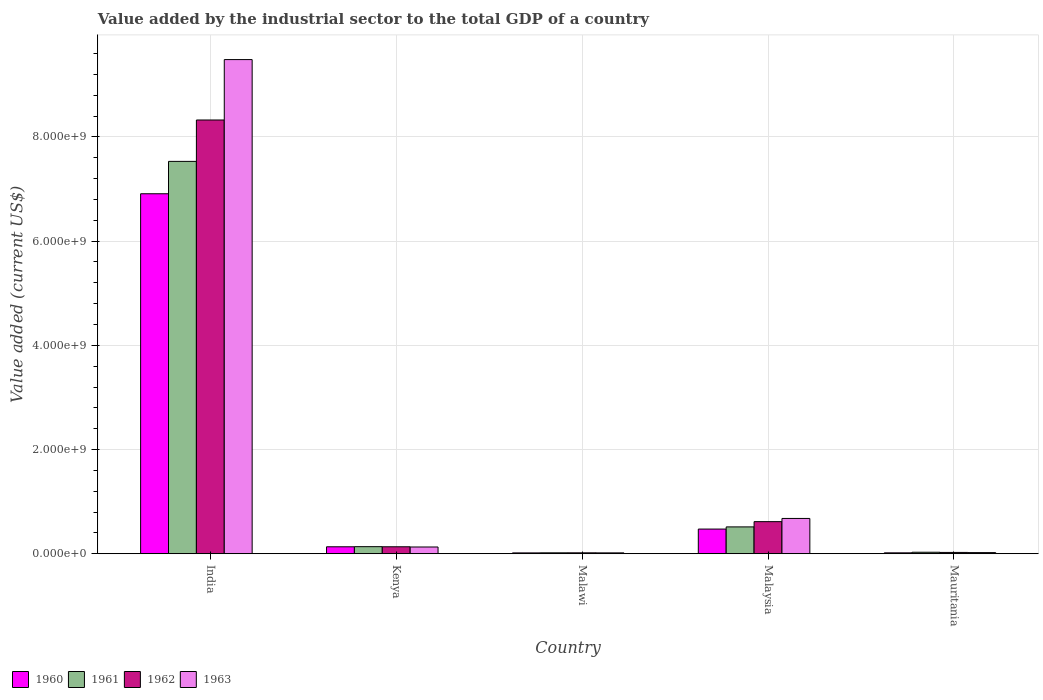How many different coloured bars are there?
Offer a terse response. 4. How many groups of bars are there?
Your answer should be compact. 5. Are the number of bars per tick equal to the number of legend labels?
Ensure brevity in your answer.  Yes. How many bars are there on the 4th tick from the left?
Your answer should be very brief. 4. How many bars are there on the 5th tick from the right?
Provide a succinct answer. 4. What is the label of the 4th group of bars from the left?
Your response must be concise. Malaysia. What is the value added by the industrial sector to the total GDP in 1962 in Mauritania?
Provide a succinct answer. 2.52e+07. Across all countries, what is the maximum value added by the industrial sector to the total GDP in 1961?
Your answer should be very brief. 7.53e+09. Across all countries, what is the minimum value added by the industrial sector to the total GDP in 1962?
Provide a succinct answer. 1.78e+07. In which country was the value added by the industrial sector to the total GDP in 1962 maximum?
Offer a very short reply. India. In which country was the value added by the industrial sector to the total GDP in 1963 minimum?
Offer a very short reply. Malawi. What is the total value added by the industrial sector to the total GDP in 1963 in the graph?
Give a very brief answer. 1.03e+1. What is the difference between the value added by the industrial sector to the total GDP in 1963 in India and that in Kenya?
Provide a succinct answer. 9.36e+09. What is the difference between the value added by the industrial sector to the total GDP in 1962 in India and the value added by the industrial sector to the total GDP in 1961 in Malawi?
Give a very brief answer. 8.31e+09. What is the average value added by the industrial sector to the total GDP in 1962 per country?
Offer a very short reply. 1.82e+09. What is the difference between the value added by the industrial sector to the total GDP of/in 1961 and value added by the industrial sector to the total GDP of/in 1962 in Kenya?
Offer a terse response. 1.96e+06. What is the ratio of the value added by the industrial sector to the total GDP in 1961 in Malawi to that in Mauritania?
Provide a succinct answer. 0.61. Is the value added by the industrial sector to the total GDP in 1961 in India less than that in Kenya?
Ensure brevity in your answer.  No. What is the difference between the highest and the second highest value added by the industrial sector to the total GDP in 1963?
Your response must be concise. 9.36e+09. What is the difference between the highest and the lowest value added by the industrial sector to the total GDP in 1961?
Your answer should be compact. 7.51e+09. In how many countries, is the value added by the industrial sector to the total GDP in 1960 greater than the average value added by the industrial sector to the total GDP in 1960 taken over all countries?
Your answer should be compact. 1. Is it the case that in every country, the sum of the value added by the industrial sector to the total GDP in 1961 and value added by the industrial sector to the total GDP in 1960 is greater than the sum of value added by the industrial sector to the total GDP in 1963 and value added by the industrial sector to the total GDP in 1962?
Offer a terse response. No. Are all the bars in the graph horizontal?
Your answer should be compact. No. How many countries are there in the graph?
Your answer should be compact. 5. Are the values on the major ticks of Y-axis written in scientific E-notation?
Offer a very short reply. Yes. Does the graph contain any zero values?
Your response must be concise. No. Does the graph contain grids?
Your answer should be very brief. Yes. Where does the legend appear in the graph?
Give a very brief answer. Bottom left. What is the title of the graph?
Ensure brevity in your answer.  Value added by the industrial sector to the total GDP of a country. Does "1997" appear as one of the legend labels in the graph?
Your response must be concise. No. What is the label or title of the X-axis?
Provide a short and direct response. Country. What is the label or title of the Y-axis?
Your answer should be compact. Value added (current US$). What is the Value added (current US$) of 1960 in India?
Your answer should be very brief. 6.91e+09. What is the Value added (current US$) in 1961 in India?
Offer a very short reply. 7.53e+09. What is the Value added (current US$) of 1962 in India?
Your answer should be very brief. 8.33e+09. What is the Value added (current US$) in 1963 in India?
Provide a succinct answer. 9.49e+09. What is the Value added (current US$) of 1960 in Kenya?
Your answer should be compact. 1.34e+08. What is the Value added (current US$) of 1961 in Kenya?
Offer a terse response. 1.36e+08. What is the Value added (current US$) in 1962 in Kenya?
Your answer should be compact. 1.34e+08. What is the Value added (current US$) of 1963 in Kenya?
Give a very brief answer. 1.30e+08. What is the Value added (current US$) in 1960 in Malawi?
Ensure brevity in your answer.  1.62e+07. What is the Value added (current US$) of 1961 in Malawi?
Offer a terse response. 1.76e+07. What is the Value added (current US$) of 1962 in Malawi?
Give a very brief answer. 1.78e+07. What is the Value added (current US$) of 1963 in Malawi?
Your answer should be compact. 1.69e+07. What is the Value added (current US$) of 1960 in Malaysia?
Provide a short and direct response. 4.74e+08. What is the Value added (current US$) in 1961 in Malaysia?
Provide a succinct answer. 5.15e+08. What is the Value added (current US$) of 1962 in Malaysia?
Ensure brevity in your answer.  6.16e+08. What is the Value added (current US$) of 1963 in Malaysia?
Provide a succinct answer. 6.77e+08. What is the Value added (current US$) of 1960 in Mauritania?
Provide a short and direct response. 1.73e+07. What is the Value added (current US$) in 1961 in Mauritania?
Make the answer very short. 2.88e+07. What is the Value added (current US$) of 1962 in Mauritania?
Offer a very short reply. 2.52e+07. What is the Value added (current US$) of 1963 in Mauritania?
Give a very brief answer. 2.18e+07. Across all countries, what is the maximum Value added (current US$) of 1960?
Make the answer very short. 6.91e+09. Across all countries, what is the maximum Value added (current US$) of 1961?
Your answer should be very brief. 7.53e+09. Across all countries, what is the maximum Value added (current US$) of 1962?
Ensure brevity in your answer.  8.33e+09. Across all countries, what is the maximum Value added (current US$) in 1963?
Offer a very short reply. 9.49e+09. Across all countries, what is the minimum Value added (current US$) of 1960?
Your answer should be very brief. 1.62e+07. Across all countries, what is the minimum Value added (current US$) of 1961?
Give a very brief answer. 1.76e+07. Across all countries, what is the minimum Value added (current US$) in 1962?
Your response must be concise. 1.78e+07. Across all countries, what is the minimum Value added (current US$) in 1963?
Your response must be concise. 1.69e+07. What is the total Value added (current US$) in 1960 in the graph?
Your answer should be compact. 7.55e+09. What is the total Value added (current US$) in 1961 in the graph?
Keep it short and to the point. 8.23e+09. What is the total Value added (current US$) of 1962 in the graph?
Provide a succinct answer. 9.12e+09. What is the total Value added (current US$) in 1963 in the graph?
Your response must be concise. 1.03e+1. What is the difference between the Value added (current US$) of 1960 in India and that in Kenya?
Keep it short and to the point. 6.78e+09. What is the difference between the Value added (current US$) in 1961 in India and that in Kenya?
Give a very brief answer. 7.40e+09. What is the difference between the Value added (current US$) in 1962 in India and that in Kenya?
Keep it short and to the point. 8.19e+09. What is the difference between the Value added (current US$) in 1963 in India and that in Kenya?
Keep it short and to the point. 9.36e+09. What is the difference between the Value added (current US$) in 1960 in India and that in Malawi?
Ensure brevity in your answer.  6.89e+09. What is the difference between the Value added (current US$) in 1961 in India and that in Malawi?
Offer a very short reply. 7.51e+09. What is the difference between the Value added (current US$) of 1962 in India and that in Malawi?
Keep it short and to the point. 8.31e+09. What is the difference between the Value added (current US$) of 1963 in India and that in Malawi?
Your answer should be very brief. 9.47e+09. What is the difference between the Value added (current US$) of 1960 in India and that in Malaysia?
Keep it short and to the point. 6.44e+09. What is the difference between the Value added (current US$) of 1961 in India and that in Malaysia?
Offer a terse response. 7.02e+09. What is the difference between the Value added (current US$) in 1962 in India and that in Malaysia?
Give a very brief answer. 7.71e+09. What is the difference between the Value added (current US$) of 1963 in India and that in Malaysia?
Your answer should be compact. 8.81e+09. What is the difference between the Value added (current US$) of 1960 in India and that in Mauritania?
Ensure brevity in your answer.  6.89e+09. What is the difference between the Value added (current US$) of 1961 in India and that in Mauritania?
Keep it short and to the point. 7.50e+09. What is the difference between the Value added (current US$) of 1962 in India and that in Mauritania?
Make the answer very short. 8.30e+09. What is the difference between the Value added (current US$) in 1963 in India and that in Mauritania?
Offer a very short reply. 9.46e+09. What is the difference between the Value added (current US$) in 1960 in Kenya and that in Malawi?
Your response must be concise. 1.17e+08. What is the difference between the Value added (current US$) of 1961 in Kenya and that in Malawi?
Make the answer very short. 1.18e+08. What is the difference between the Value added (current US$) in 1962 in Kenya and that in Malawi?
Your answer should be very brief. 1.16e+08. What is the difference between the Value added (current US$) in 1963 in Kenya and that in Malawi?
Your answer should be very brief. 1.13e+08. What is the difference between the Value added (current US$) in 1960 in Kenya and that in Malaysia?
Keep it short and to the point. -3.40e+08. What is the difference between the Value added (current US$) of 1961 in Kenya and that in Malaysia?
Make the answer very short. -3.79e+08. What is the difference between the Value added (current US$) of 1962 in Kenya and that in Malaysia?
Provide a succinct answer. -4.82e+08. What is the difference between the Value added (current US$) of 1963 in Kenya and that in Malaysia?
Offer a very short reply. -5.48e+08. What is the difference between the Value added (current US$) in 1960 in Kenya and that in Mauritania?
Make the answer very short. 1.16e+08. What is the difference between the Value added (current US$) of 1961 in Kenya and that in Mauritania?
Keep it short and to the point. 1.07e+08. What is the difference between the Value added (current US$) of 1962 in Kenya and that in Mauritania?
Your answer should be compact. 1.09e+08. What is the difference between the Value added (current US$) in 1963 in Kenya and that in Mauritania?
Offer a terse response. 1.08e+08. What is the difference between the Value added (current US$) in 1960 in Malawi and that in Malaysia?
Make the answer very short. -4.57e+08. What is the difference between the Value added (current US$) in 1961 in Malawi and that in Malaysia?
Offer a very short reply. -4.98e+08. What is the difference between the Value added (current US$) in 1962 in Malawi and that in Malaysia?
Provide a succinct answer. -5.98e+08. What is the difference between the Value added (current US$) of 1963 in Malawi and that in Malaysia?
Make the answer very short. -6.61e+08. What is the difference between the Value added (current US$) of 1960 in Malawi and that in Mauritania?
Give a very brief answer. -1.06e+06. What is the difference between the Value added (current US$) in 1961 in Malawi and that in Mauritania?
Your answer should be compact. -1.12e+07. What is the difference between the Value added (current US$) in 1962 in Malawi and that in Mauritania?
Make the answer very short. -7.44e+06. What is the difference between the Value added (current US$) in 1963 in Malawi and that in Mauritania?
Provide a succinct answer. -4.90e+06. What is the difference between the Value added (current US$) in 1960 in Malaysia and that in Mauritania?
Your answer should be compact. 4.56e+08. What is the difference between the Value added (current US$) in 1961 in Malaysia and that in Mauritania?
Your response must be concise. 4.87e+08. What is the difference between the Value added (current US$) in 1962 in Malaysia and that in Mauritania?
Your answer should be very brief. 5.91e+08. What is the difference between the Value added (current US$) in 1963 in Malaysia and that in Mauritania?
Provide a succinct answer. 6.56e+08. What is the difference between the Value added (current US$) in 1960 in India and the Value added (current US$) in 1961 in Kenya?
Your response must be concise. 6.77e+09. What is the difference between the Value added (current US$) of 1960 in India and the Value added (current US$) of 1962 in Kenya?
Offer a terse response. 6.78e+09. What is the difference between the Value added (current US$) of 1960 in India and the Value added (current US$) of 1963 in Kenya?
Your answer should be very brief. 6.78e+09. What is the difference between the Value added (current US$) of 1961 in India and the Value added (current US$) of 1962 in Kenya?
Ensure brevity in your answer.  7.40e+09. What is the difference between the Value added (current US$) in 1961 in India and the Value added (current US$) in 1963 in Kenya?
Your answer should be very brief. 7.40e+09. What is the difference between the Value added (current US$) of 1962 in India and the Value added (current US$) of 1963 in Kenya?
Offer a terse response. 8.20e+09. What is the difference between the Value added (current US$) of 1960 in India and the Value added (current US$) of 1961 in Malawi?
Provide a short and direct response. 6.89e+09. What is the difference between the Value added (current US$) of 1960 in India and the Value added (current US$) of 1962 in Malawi?
Provide a short and direct response. 6.89e+09. What is the difference between the Value added (current US$) of 1960 in India and the Value added (current US$) of 1963 in Malawi?
Make the answer very short. 6.89e+09. What is the difference between the Value added (current US$) in 1961 in India and the Value added (current US$) in 1962 in Malawi?
Provide a short and direct response. 7.51e+09. What is the difference between the Value added (current US$) of 1961 in India and the Value added (current US$) of 1963 in Malawi?
Offer a very short reply. 7.51e+09. What is the difference between the Value added (current US$) in 1962 in India and the Value added (current US$) in 1963 in Malawi?
Ensure brevity in your answer.  8.31e+09. What is the difference between the Value added (current US$) in 1960 in India and the Value added (current US$) in 1961 in Malaysia?
Provide a short and direct response. 6.39e+09. What is the difference between the Value added (current US$) in 1960 in India and the Value added (current US$) in 1962 in Malaysia?
Your response must be concise. 6.29e+09. What is the difference between the Value added (current US$) in 1960 in India and the Value added (current US$) in 1963 in Malaysia?
Provide a short and direct response. 6.23e+09. What is the difference between the Value added (current US$) of 1961 in India and the Value added (current US$) of 1962 in Malaysia?
Your answer should be very brief. 6.92e+09. What is the difference between the Value added (current US$) in 1961 in India and the Value added (current US$) in 1963 in Malaysia?
Ensure brevity in your answer.  6.85e+09. What is the difference between the Value added (current US$) in 1962 in India and the Value added (current US$) in 1963 in Malaysia?
Your answer should be very brief. 7.65e+09. What is the difference between the Value added (current US$) of 1960 in India and the Value added (current US$) of 1961 in Mauritania?
Offer a terse response. 6.88e+09. What is the difference between the Value added (current US$) of 1960 in India and the Value added (current US$) of 1962 in Mauritania?
Provide a succinct answer. 6.88e+09. What is the difference between the Value added (current US$) of 1960 in India and the Value added (current US$) of 1963 in Mauritania?
Ensure brevity in your answer.  6.89e+09. What is the difference between the Value added (current US$) of 1961 in India and the Value added (current US$) of 1962 in Mauritania?
Offer a very short reply. 7.51e+09. What is the difference between the Value added (current US$) of 1961 in India and the Value added (current US$) of 1963 in Mauritania?
Ensure brevity in your answer.  7.51e+09. What is the difference between the Value added (current US$) in 1962 in India and the Value added (current US$) in 1963 in Mauritania?
Offer a very short reply. 8.30e+09. What is the difference between the Value added (current US$) in 1960 in Kenya and the Value added (current US$) in 1961 in Malawi?
Keep it short and to the point. 1.16e+08. What is the difference between the Value added (current US$) of 1960 in Kenya and the Value added (current US$) of 1962 in Malawi?
Your answer should be very brief. 1.16e+08. What is the difference between the Value added (current US$) in 1960 in Kenya and the Value added (current US$) in 1963 in Malawi?
Provide a succinct answer. 1.17e+08. What is the difference between the Value added (current US$) in 1961 in Kenya and the Value added (current US$) in 1962 in Malawi?
Your answer should be compact. 1.18e+08. What is the difference between the Value added (current US$) of 1961 in Kenya and the Value added (current US$) of 1963 in Malawi?
Offer a very short reply. 1.19e+08. What is the difference between the Value added (current US$) of 1962 in Kenya and the Value added (current US$) of 1963 in Malawi?
Your answer should be very brief. 1.17e+08. What is the difference between the Value added (current US$) of 1960 in Kenya and the Value added (current US$) of 1961 in Malaysia?
Your answer should be very brief. -3.82e+08. What is the difference between the Value added (current US$) of 1960 in Kenya and the Value added (current US$) of 1962 in Malaysia?
Ensure brevity in your answer.  -4.82e+08. What is the difference between the Value added (current US$) in 1960 in Kenya and the Value added (current US$) in 1963 in Malaysia?
Your answer should be compact. -5.44e+08. What is the difference between the Value added (current US$) in 1961 in Kenya and the Value added (current US$) in 1962 in Malaysia?
Your response must be concise. -4.80e+08. What is the difference between the Value added (current US$) in 1961 in Kenya and the Value added (current US$) in 1963 in Malaysia?
Your answer should be very brief. -5.42e+08. What is the difference between the Value added (current US$) of 1962 in Kenya and the Value added (current US$) of 1963 in Malaysia?
Make the answer very short. -5.44e+08. What is the difference between the Value added (current US$) of 1960 in Kenya and the Value added (current US$) of 1961 in Mauritania?
Your answer should be very brief. 1.05e+08. What is the difference between the Value added (current US$) of 1960 in Kenya and the Value added (current US$) of 1962 in Mauritania?
Ensure brevity in your answer.  1.08e+08. What is the difference between the Value added (current US$) of 1960 in Kenya and the Value added (current US$) of 1963 in Mauritania?
Provide a succinct answer. 1.12e+08. What is the difference between the Value added (current US$) of 1961 in Kenya and the Value added (current US$) of 1962 in Mauritania?
Offer a terse response. 1.11e+08. What is the difference between the Value added (current US$) of 1961 in Kenya and the Value added (current US$) of 1963 in Mauritania?
Your answer should be very brief. 1.14e+08. What is the difference between the Value added (current US$) in 1962 in Kenya and the Value added (current US$) in 1963 in Mauritania?
Make the answer very short. 1.12e+08. What is the difference between the Value added (current US$) in 1960 in Malawi and the Value added (current US$) in 1961 in Malaysia?
Offer a terse response. -4.99e+08. What is the difference between the Value added (current US$) of 1960 in Malawi and the Value added (current US$) of 1962 in Malaysia?
Your answer should be compact. -6.00e+08. What is the difference between the Value added (current US$) in 1960 in Malawi and the Value added (current US$) in 1963 in Malaysia?
Provide a succinct answer. -6.61e+08. What is the difference between the Value added (current US$) of 1961 in Malawi and the Value added (current US$) of 1962 in Malaysia?
Provide a short and direct response. -5.98e+08. What is the difference between the Value added (current US$) in 1961 in Malawi and the Value added (current US$) in 1963 in Malaysia?
Your answer should be very brief. -6.60e+08. What is the difference between the Value added (current US$) of 1962 in Malawi and the Value added (current US$) of 1963 in Malaysia?
Offer a very short reply. -6.60e+08. What is the difference between the Value added (current US$) of 1960 in Malawi and the Value added (current US$) of 1961 in Mauritania?
Keep it short and to the point. -1.26e+07. What is the difference between the Value added (current US$) in 1960 in Malawi and the Value added (current US$) in 1962 in Mauritania?
Provide a succinct answer. -8.98e+06. What is the difference between the Value added (current US$) of 1960 in Malawi and the Value added (current US$) of 1963 in Mauritania?
Your answer should be very brief. -5.60e+06. What is the difference between the Value added (current US$) of 1961 in Malawi and the Value added (current US$) of 1962 in Mauritania?
Give a very brief answer. -7.58e+06. What is the difference between the Value added (current US$) of 1961 in Malawi and the Value added (current US$) of 1963 in Mauritania?
Your answer should be compact. -4.20e+06. What is the difference between the Value added (current US$) of 1962 in Malawi and the Value added (current US$) of 1963 in Mauritania?
Your response must be concise. -4.06e+06. What is the difference between the Value added (current US$) in 1960 in Malaysia and the Value added (current US$) in 1961 in Mauritania?
Offer a very short reply. 4.45e+08. What is the difference between the Value added (current US$) of 1960 in Malaysia and the Value added (current US$) of 1962 in Mauritania?
Keep it short and to the point. 4.48e+08. What is the difference between the Value added (current US$) of 1960 in Malaysia and the Value added (current US$) of 1963 in Mauritania?
Make the answer very short. 4.52e+08. What is the difference between the Value added (current US$) in 1961 in Malaysia and the Value added (current US$) in 1962 in Mauritania?
Make the answer very short. 4.90e+08. What is the difference between the Value added (current US$) in 1961 in Malaysia and the Value added (current US$) in 1963 in Mauritania?
Provide a short and direct response. 4.94e+08. What is the difference between the Value added (current US$) in 1962 in Malaysia and the Value added (current US$) in 1963 in Mauritania?
Give a very brief answer. 5.94e+08. What is the average Value added (current US$) of 1960 per country?
Provide a short and direct response. 1.51e+09. What is the average Value added (current US$) in 1961 per country?
Your response must be concise. 1.65e+09. What is the average Value added (current US$) of 1962 per country?
Offer a terse response. 1.82e+09. What is the average Value added (current US$) of 1963 per country?
Your answer should be compact. 2.07e+09. What is the difference between the Value added (current US$) in 1960 and Value added (current US$) in 1961 in India?
Give a very brief answer. -6.21e+08. What is the difference between the Value added (current US$) in 1960 and Value added (current US$) in 1962 in India?
Offer a very short reply. -1.42e+09. What is the difference between the Value added (current US$) in 1960 and Value added (current US$) in 1963 in India?
Give a very brief answer. -2.58e+09. What is the difference between the Value added (current US$) in 1961 and Value added (current US$) in 1962 in India?
Provide a short and direct response. -7.94e+08. What is the difference between the Value added (current US$) in 1961 and Value added (current US$) in 1963 in India?
Offer a terse response. -1.95e+09. What is the difference between the Value added (current US$) of 1962 and Value added (current US$) of 1963 in India?
Provide a succinct answer. -1.16e+09. What is the difference between the Value added (current US$) of 1960 and Value added (current US$) of 1961 in Kenya?
Provide a succinct answer. -2.25e+06. What is the difference between the Value added (current US$) in 1960 and Value added (current US$) in 1962 in Kenya?
Provide a short and direct response. -2.94e+05. What is the difference between the Value added (current US$) in 1960 and Value added (current US$) in 1963 in Kenya?
Give a very brief answer. 4.12e+06. What is the difference between the Value added (current US$) of 1961 and Value added (current US$) of 1962 in Kenya?
Give a very brief answer. 1.96e+06. What is the difference between the Value added (current US$) of 1961 and Value added (current US$) of 1963 in Kenya?
Make the answer very short. 6.37e+06. What is the difference between the Value added (current US$) of 1962 and Value added (current US$) of 1963 in Kenya?
Keep it short and to the point. 4.41e+06. What is the difference between the Value added (current US$) of 1960 and Value added (current US$) of 1961 in Malawi?
Ensure brevity in your answer.  -1.40e+06. What is the difference between the Value added (current US$) of 1960 and Value added (current US$) of 1962 in Malawi?
Provide a short and direct response. -1.54e+06. What is the difference between the Value added (current US$) in 1960 and Value added (current US$) in 1963 in Malawi?
Offer a very short reply. -7.00e+05. What is the difference between the Value added (current US$) in 1961 and Value added (current US$) in 1962 in Malawi?
Your answer should be compact. -1.40e+05. What is the difference between the Value added (current US$) in 1961 and Value added (current US$) in 1963 in Malawi?
Give a very brief answer. 7.00e+05. What is the difference between the Value added (current US$) of 1962 and Value added (current US$) of 1963 in Malawi?
Your response must be concise. 8.40e+05. What is the difference between the Value added (current US$) of 1960 and Value added (current US$) of 1961 in Malaysia?
Offer a very short reply. -4.19e+07. What is the difference between the Value added (current US$) in 1960 and Value added (current US$) in 1962 in Malaysia?
Provide a succinct answer. -1.43e+08. What is the difference between the Value added (current US$) of 1960 and Value added (current US$) of 1963 in Malaysia?
Offer a very short reply. -2.04e+08. What is the difference between the Value added (current US$) in 1961 and Value added (current US$) in 1962 in Malaysia?
Provide a short and direct response. -1.01e+08. What is the difference between the Value added (current US$) in 1961 and Value added (current US$) in 1963 in Malaysia?
Ensure brevity in your answer.  -1.62e+08. What is the difference between the Value added (current US$) of 1962 and Value added (current US$) of 1963 in Malaysia?
Offer a terse response. -6.14e+07. What is the difference between the Value added (current US$) in 1960 and Value added (current US$) in 1961 in Mauritania?
Offer a very short reply. -1.15e+07. What is the difference between the Value added (current US$) of 1960 and Value added (current US$) of 1962 in Mauritania?
Provide a short and direct response. -7.93e+06. What is the difference between the Value added (current US$) of 1960 and Value added (current US$) of 1963 in Mauritania?
Offer a very short reply. -4.55e+06. What is the difference between the Value added (current US$) in 1961 and Value added (current US$) in 1962 in Mauritania?
Keep it short and to the point. 3.60e+06. What is the difference between the Value added (current US$) in 1961 and Value added (current US$) in 1963 in Mauritania?
Give a very brief answer. 6.98e+06. What is the difference between the Value added (current US$) of 1962 and Value added (current US$) of 1963 in Mauritania?
Provide a succinct answer. 3.38e+06. What is the ratio of the Value added (current US$) of 1960 in India to that in Kenya?
Make the answer very short. 51.7. What is the ratio of the Value added (current US$) of 1961 in India to that in Kenya?
Keep it short and to the point. 55.42. What is the ratio of the Value added (current US$) in 1962 in India to that in Kenya?
Your answer should be very brief. 62.16. What is the ratio of the Value added (current US$) of 1963 in India to that in Kenya?
Your response must be concise. 73.23. What is the ratio of the Value added (current US$) of 1960 in India to that in Malawi?
Offer a terse response. 425.49. What is the ratio of the Value added (current US$) of 1961 in India to that in Malawi?
Ensure brevity in your answer.  426.94. What is the ratio of the Value added (current US$) of 1962 in India to that in Malawi?
Your answer should be compact. 468.26. What is the ratio of the Value added (current US$) in 1963 in India to that in Malawi?
Make the answer very short. 559.94. What is the ratio of the Value added (current US$) of 1960 in India to that in Malaysia?
Your answer should be very brief. 14.59. What is the ratio of the Value added (current US$) in 1961 in India to that in Malaysia?
Ensure brevity in your answer.  14.61. What is the ratio of the Value added (current US$) of 1962 in India to that in Malaysia?
Provide a succinct answer. 13.51. What is the ratio of the Value added (current US$) of 1963 in India to that in Malaysia?
Keep it short and to the point. 14. What is the ratio of the Value added (current US$) in 1960 in India to that in Mauritania?
Provide a short and direct response. 399.54. What is the ratio of the Value added (current US$) of 1961 in India to that in Mauritania?
Offer a terse response. 261.27. What is the ratio of the Value added (current US$) in 1962 in India to that in Mauritania?
Your answer should be very brief. 330.1. What is the ratio of the Value added (current US$) of 1963 in India to that in Mauritania?
Offer a terse response. 434.24. What is the ratio of the Value added (current US$) in 1960 in Kenya to that in Malawi?
Your answer should be compact. 8.23. What is the ratio of the Value added (current US$) of 1961 in Kenya to that in Malawi?
Ensure brevity in your answer.  7.7. What is the ratio of the Value added (current US$) of 1962 in Kenya to that in Malawi?
Give a very brief answer. 7.53. What is the ratio of the Value added (current US$) of 1963 in Kenya to that in Malawi?
Provide a short and direct response. 7.65. What is the ratio of the Value added (current US$) in 1960 in Kenya to that in Malaysia?
Offer a very short reply. 0.28. What is the ratio of the Value added (current US$) in 1961 in Kenya to that in Malaysia?
Your answer should be compact. 0.26. What is the ratio of the Value added (current US$) in 1962 in Kenya to that in Malaysia?
Ensure brevity in your answer.  0.22. What is the ratio of the Value added (current US$) in 1963 in Kenya to that in Malaysia?
Ensure brevity in your answer.  0.19. What is the ratio of the Value added (current US$) in 1960 in Kenya to that in Mauritania?
Make the answer very short. 7.73. What is the ratio of the Value added (current US$) of 1961 in Kenya to that in Mauritania?
Provide a short and direct response. 4.71. What is the ratio of the Value added (current US$) in 1962 in Kenya to that in Mauritania?
Provide a succinct answer. 5.31. What is the ratio of the Value added (current US$) in 1963 in Kenya to that in Mauritania?
Offer a very short reply. 5.93. What is the ratio of the Value added (current US$) of 1960 in Malawi to that in Malaysia?
Offer a very short reply. 0.03. What is the ratio of the Value added (current US$) of 1961 in Malawi to that in Malaysia?
Offer a terse response. 0.03. What is the ratio of the Value added (current US$) of 1962 in Malawi to that in Malaysia?
Give a very brief answer. 0.03. What is the ratio of the Value added (current US$) of 1963 in Malawi to that in Malaysia?
Ensure brevity in your answer.  0.03. What is the ratio of the Value added (current US$) of 1960 in Malawi to that in Mauritania?
Offer a very short reply. 0.94. What is the ratio of the Value added (current US$) of 1961 in Malawi to that in Mauritania?
Give a very brief answer. 0.61. What is the ratio of the Value added (current US$) in 1962 in Malawi to that in Mauritania?
Offer a terse response. 0.7. What is the ratio of the Value added (current US$) of 1963 in Malawi to that in Mauritania?
Offer a terse response. 0.78. What is the ratio of the Value added (current US$) of 1960 in Malaysia to that in Mauritania?
Your answer should be very brief. 27.38. What is the ratio of the Value added (current US$) of 1961 in Malaysia to that in Mauritania?
Your response must be concise. 17.88. What is the ratio of the Value added (current US$) in 1962 in Malaysia to that in Mauritania?
Ensure brevity in your answer.  24.43. What is the ratio of the Value added (current US$) of 1963 in Malaysia to that in Mauritania?
Ensure brevity in your answer.  31.01. What is the difference between the highest and the second highest Value added (current US$) in 1960?
Your answer should be compact. 6.44e+09. What is the difference between the highest and the second highest Value added (current US$) in 1961?
Provide a succinct answer. 7.02e+09. What is the difference between the highest and the second highest Value added (current US$) in 1962?
Provide a short and direct response. 7.71e+09. What is the difference between the highest and the second highest Value added (current US$) of 1963?
Provide a short and direct response. 8.81e+09. What is the difference between the highest and the lowest Value added (current US$) of 1960?
Provide a short and direct response. 6.89e+09. What is the difference between the highest and the lowest Value added (current US$) of 1961?
Offer a very short reply. 7.51e+09. What is the difference between the highest and the lowest Value added (current US$) of 1962?
Give a very brief answer. 8.31e+09. What is the difference between the highest and the lowest Value added (current US$) of 1963?
Your answer should be compact. 9.47e+09. 